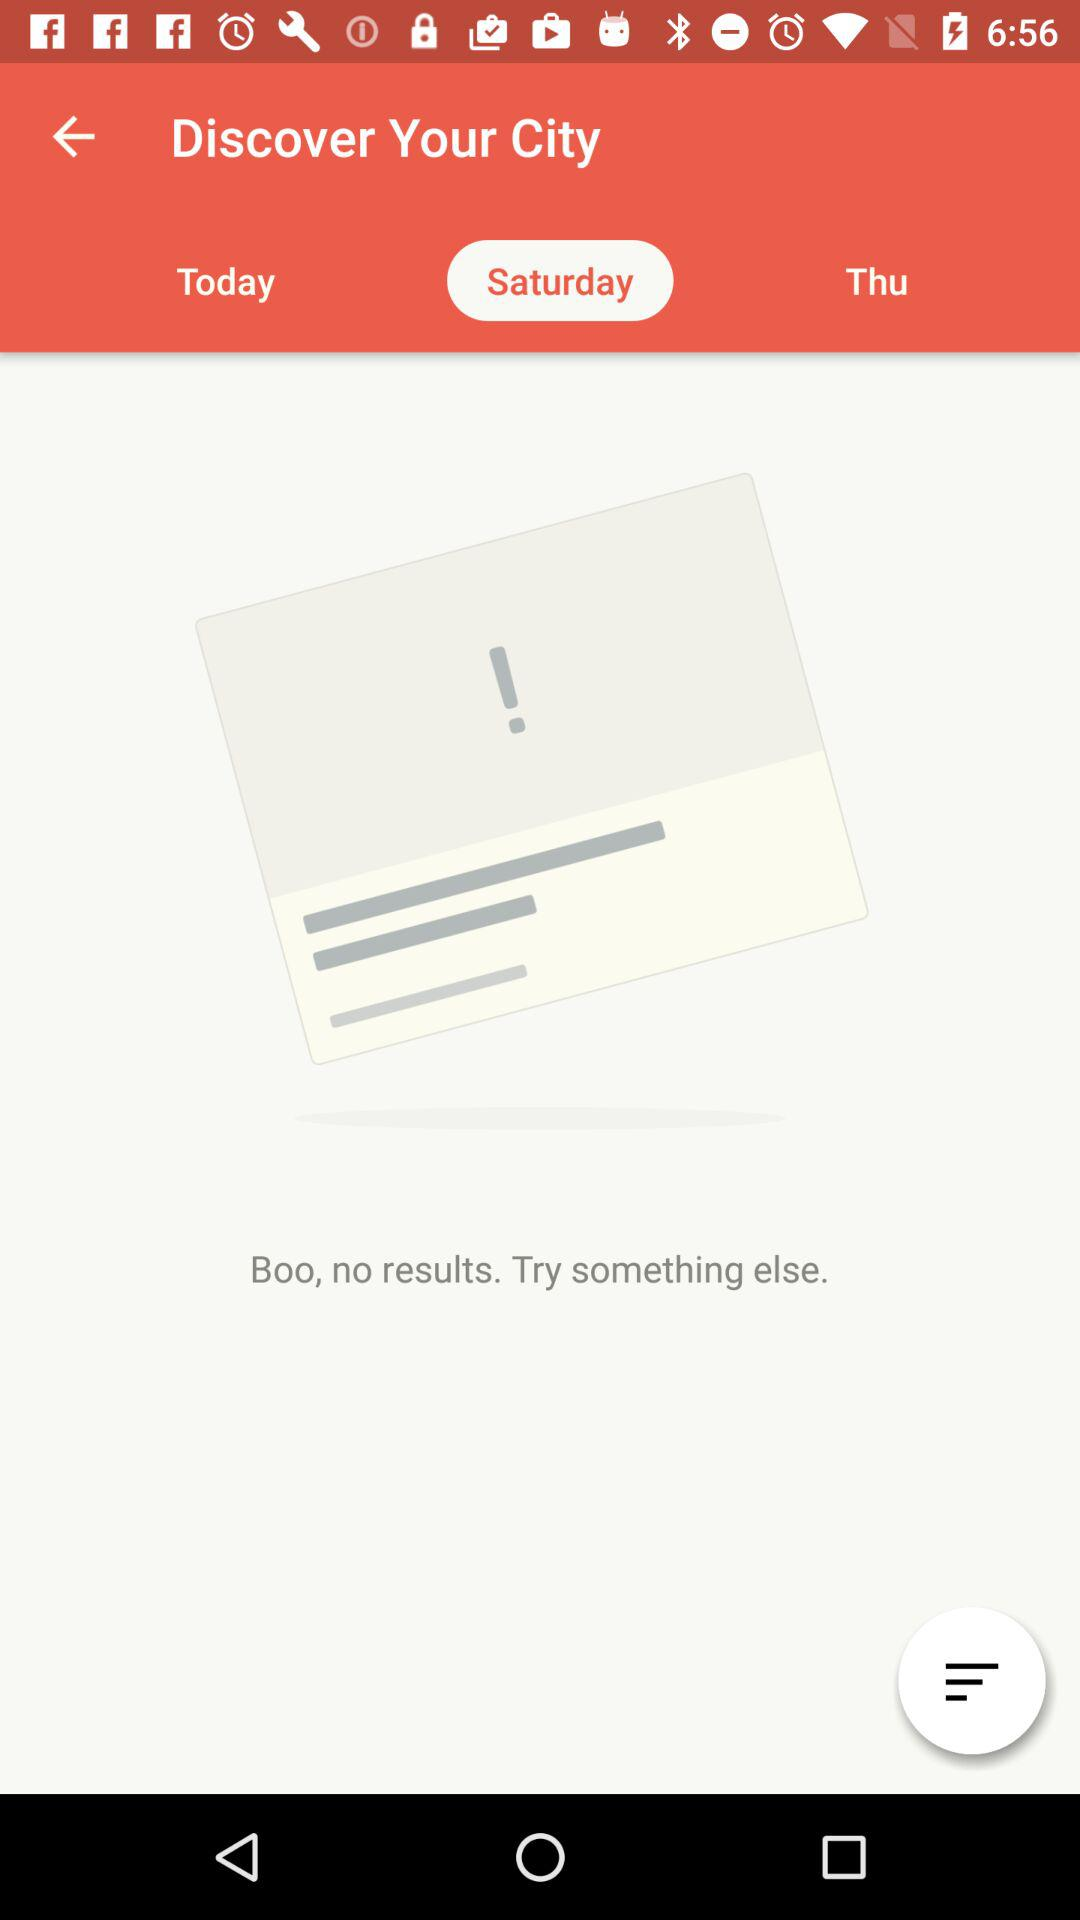Which tab is selected? The selected tab is "Saturday". 